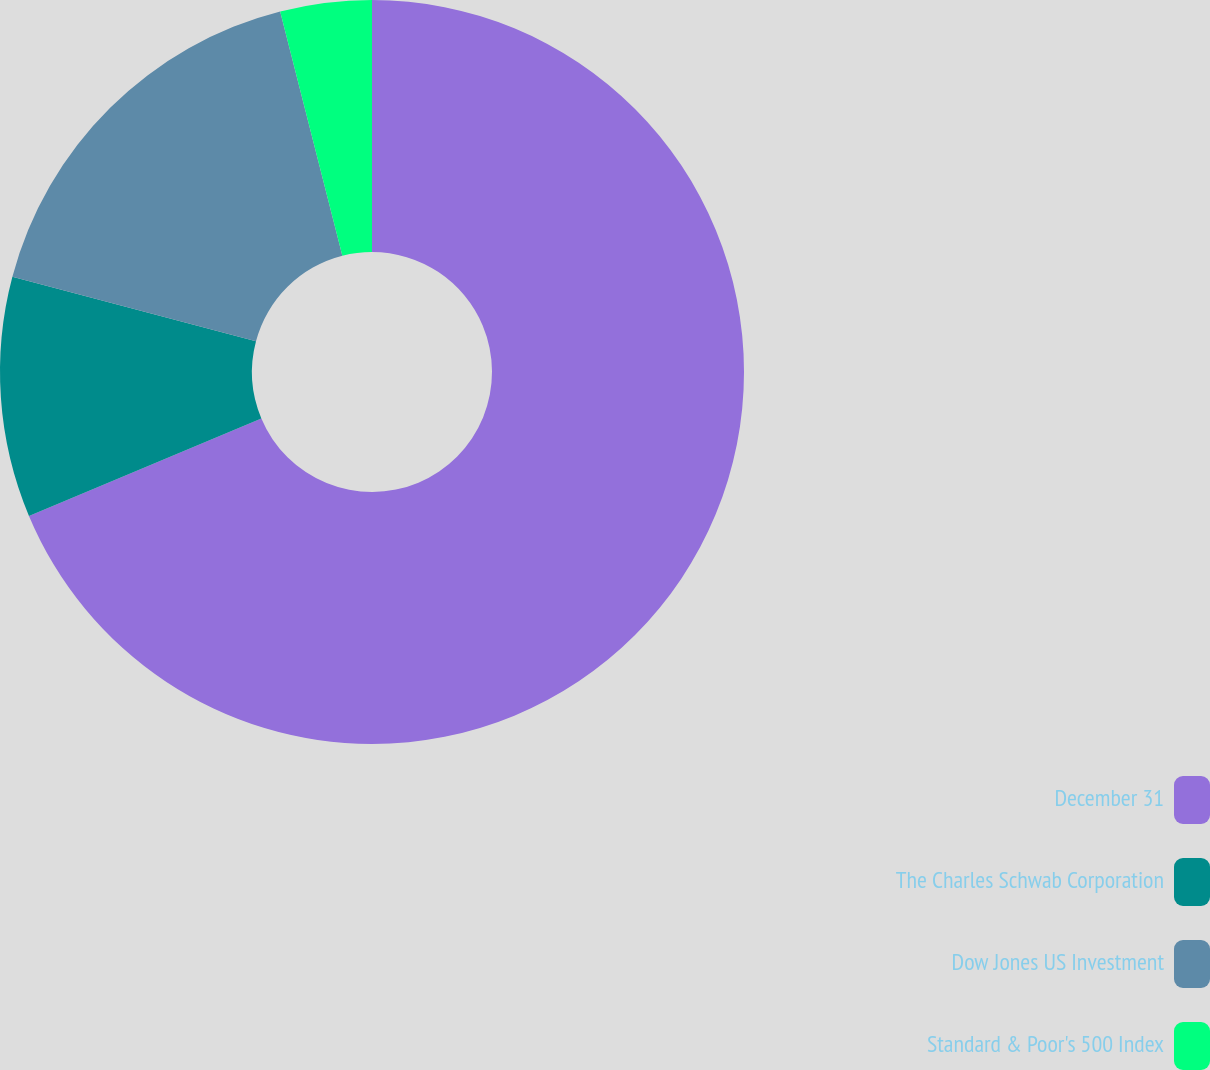Convert chart to OTSL. <chart><loc_0><loc_0><loc_500><loc_500><pie_chart><fcel>December 31<fcel>The Charles Schwab Corporation<fcel>Dow Jones US Investment<fcel>Standard & Poor's 500 Index<nl><fcel>68.67%<fcel>10.44%<fcel>16.91%<fcel>3.97%<nl></chart> 